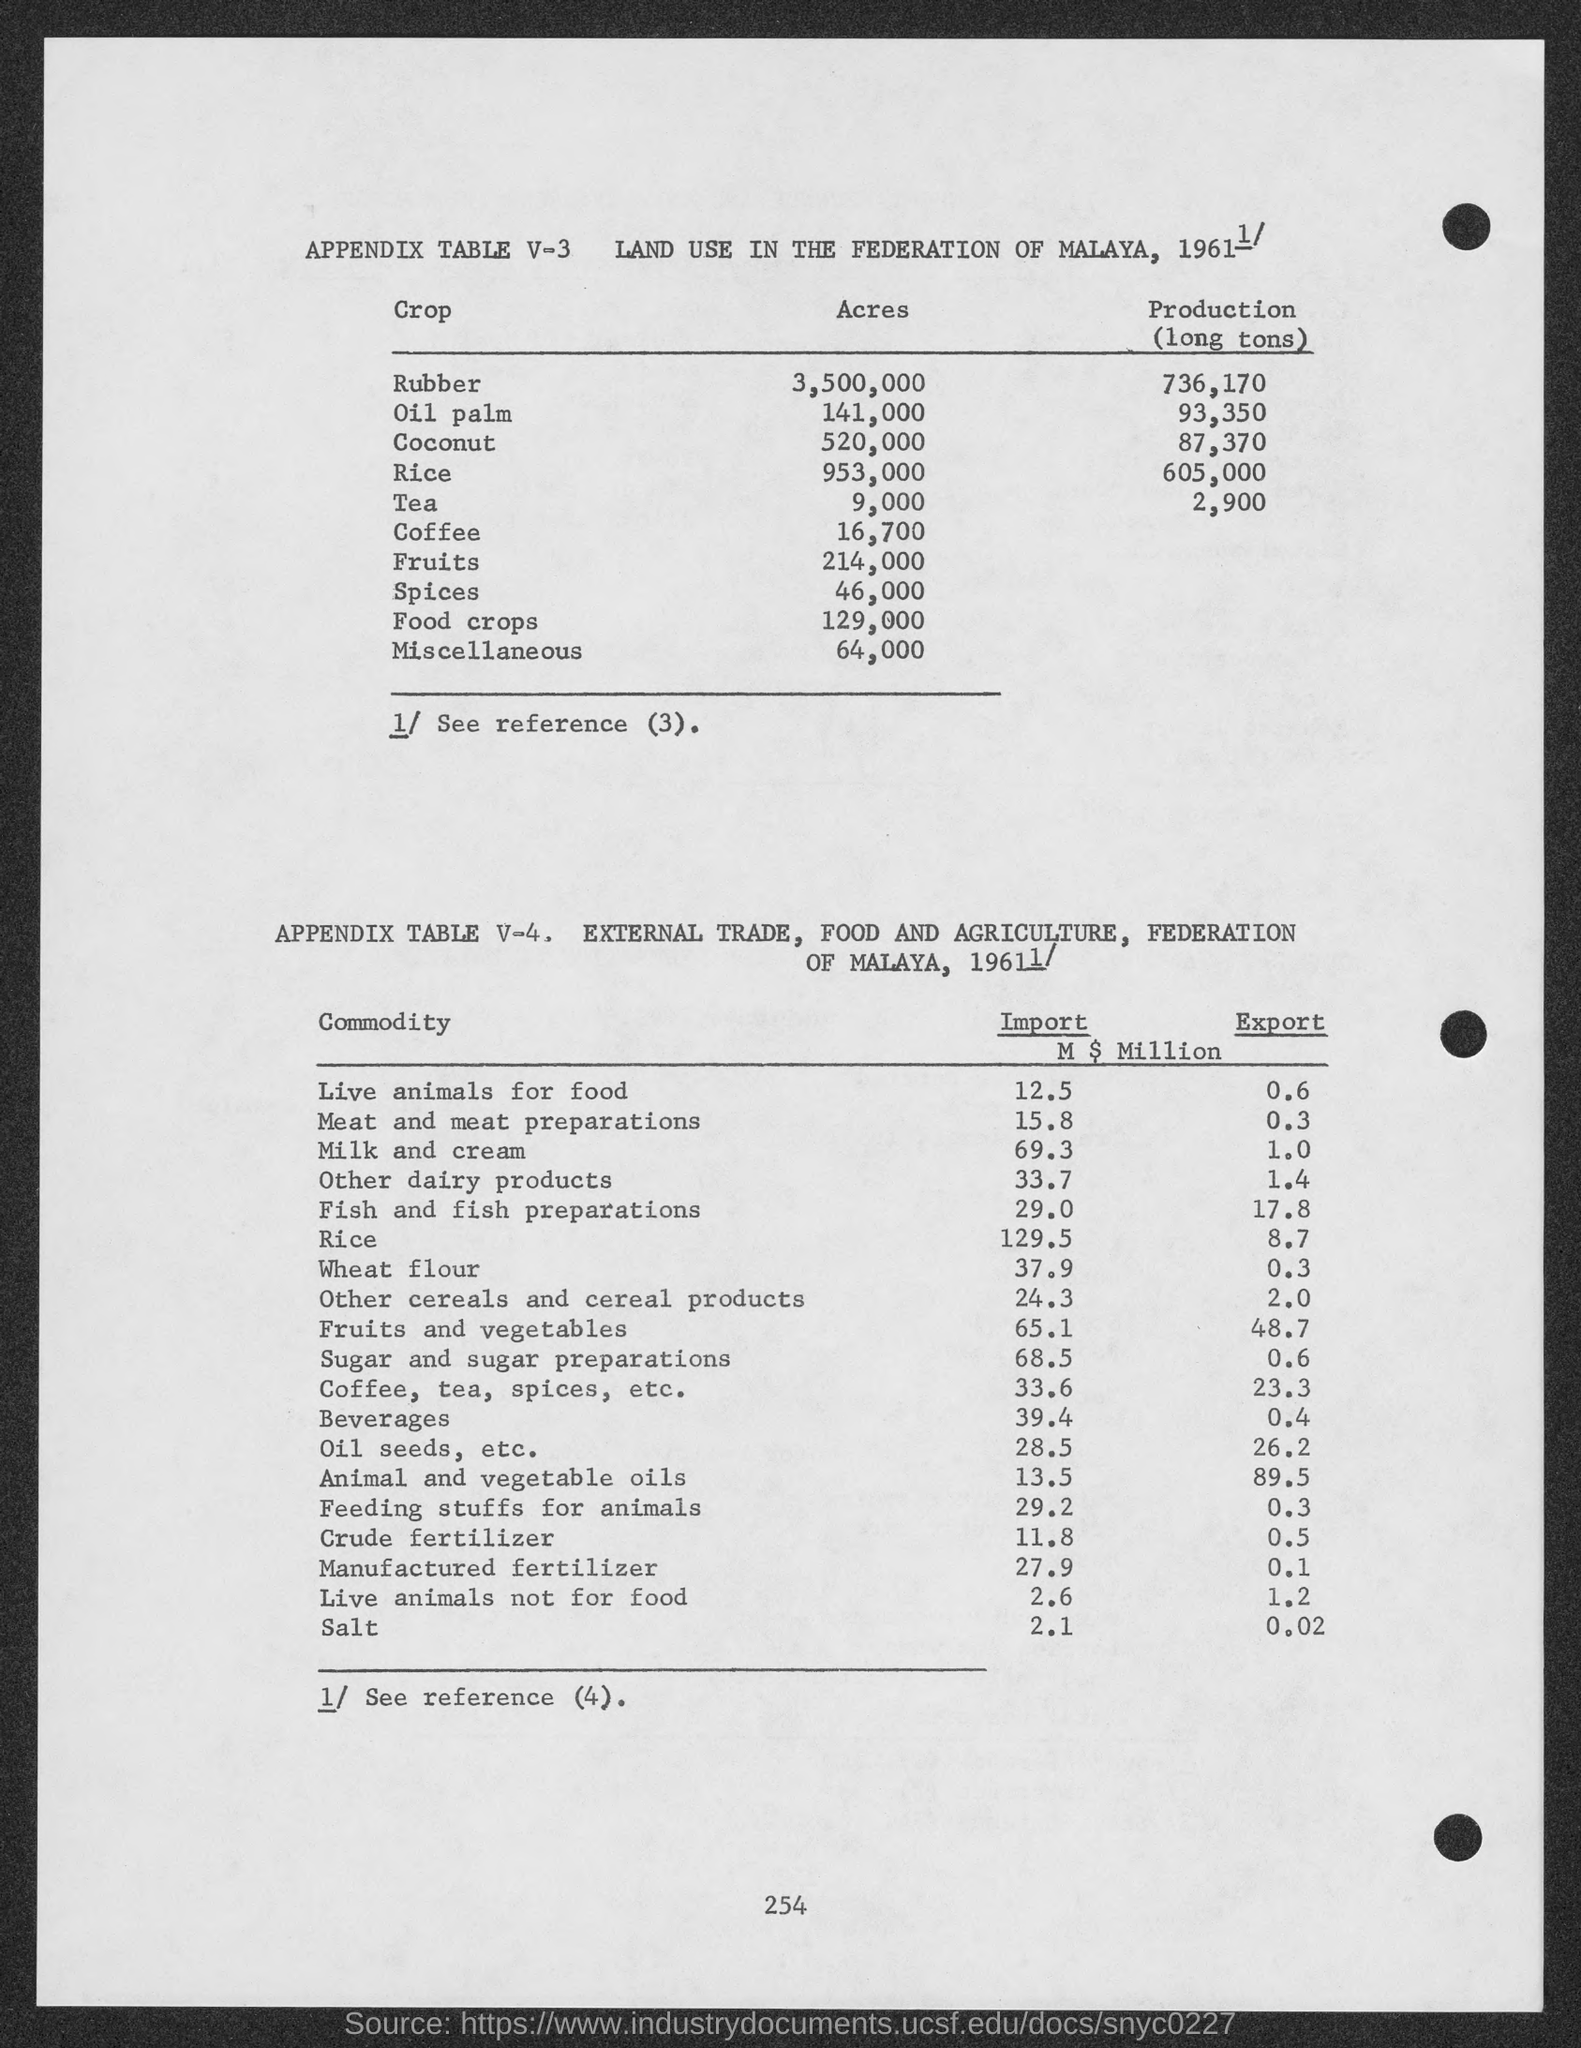How many acres of Rubber?
Offer a very short reply. 3,500,000. How many acres of Oil Palm?
Give a very brief answer. 141,000. How many acres of Coconut?
Your answer should be very brief. 520,000. How many acres of Rice?
Keep it short and to the point. 953,000. How many acres of Tea?
Keep it short and to the point. 9,000. How many acres of Coffee?
Keep it short and to the point. 16,700. How many acres of Fruits?
Keep it short and to the point. 214,000. How many acres of spices?
Ensure brevity in your answer.  46,000. How many acres of food crops?
Your answer should be very brief. 129,000. How many acres of Miscellaneous?
Provide a short and direct response. 64,000. 